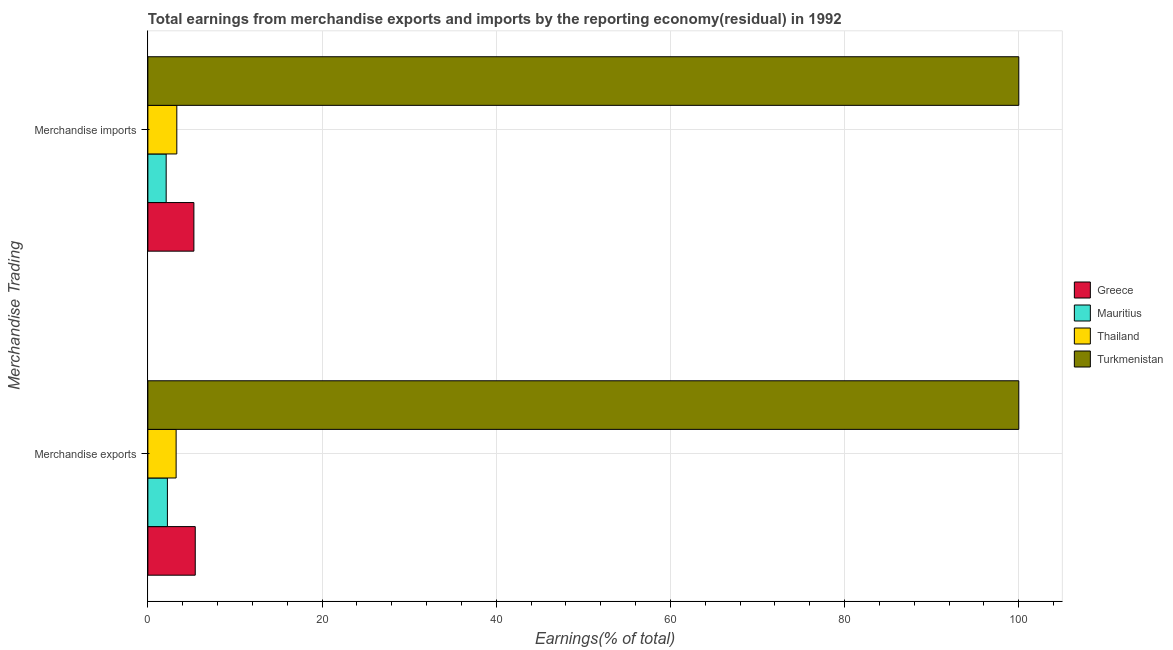How many groups of bars are there?
Your answer should be very brief. 2. Are the number of bars per tick equal to the number of legend labels?
Provide a succinct answer. Yes. How many bars are there on the 1st tick from the top?
Provide a succinct answer. 4. How many bars are there on the 2nd tick from the bottom?
Provide a short and direct response. 4. What is the label of the 1st group of bars from the top?
Offer a terse response. Merchandise imports. Across all countries, what is the minimum earnings from merchandise imports?
Offer a very short reply. 2.1. In which country was the earnings from merchandise imports maximum?
Ensure brevity in your answer.  Turkmenistan. In which country was the earnings from merchandise imports minimum?
Make the answer very short. Mauritius. What is the total earnings from merchandise imports in the graph?
Keep it short and to the point. 110.71. What is the difference between the earnings from merchandise imports in Mauritius and that in Turkmenistan?
Your answer should be very brief. -97.9. What is the difference between the earnings from merchandise exports in Thailand and the earnings from merchandise imports in Turkmenistan?
Your answer should be compact. -96.75. What is the average earnings from merchandise exports per country?
Your response must be concise. 27.73. What is the ratio of the earnings from merchandise exports in Turkmenistan to that in Thailand?
Your answer should be very brief. 30.81. Is the earnings from merchandise exports in Mauritius less than that in Turkmenistan?
Give a very brief answer. Yes. In how many countries, is the earnings from merchandise imports greater than the average earnings from merchandise imports taken over all countries?
Your answer should be very brief. 1. Are all the bars in the graph horizontal?
Offer a terse response. Yes. How many countries are there in the graph?
Your answer should be compact. 4. What is the difference between two consecutive major ticks on the X-axis?
Offer a very short reply. 20. Are the values on the major ticks of X-axis written in scientific E-notation?
Offer a very short reply. No. Does the graph contain grids?
Ensure brevity in your answer.  Yes. Where does the legend appear in the graph?
Offer a very short reply. Center right. How many legend labels are there?
Provide a short and direct response. 4. What is the title of the graph?
Your answer should be compact. Total earnings from merchandise exports and imports by the reporting economy(residual) in 1992. What is the label or title of the X-axis?
Provide a short and direct response. Earnings(% of total). What is the label or title of the Y-axis?
Offer a very short reply. Merchandise Trading. What is the Earnings(% of total) of Greece in Merchandise exports?
Your answer should be compact. 5.44. What is the Earnings(% of total) of Mauritius in Merchandise exports?
Offer a terse response. 2.24. What is the Earnings(% of total) of Thailand in Merchandise exports?
Provide a succinct answer. 3.25. What is the Earnings(% of total) of Turkmenistan in Merchandise exports?
Your response must be concise. 100. What is the Earnings(% of total) of Greece in Merchandise imports?
Provide a succinct answer. 5.28. What is the Earnings(% of total) in Mauritius in Merchandise imports?
Provide a succinct answer. 2.1. What is the Earnings(% of total) in Thailand in Merchandise imports?
Give a very brief answer. 3.32. What is the Earnings(% of total) in Turkmenistan in Merchandise imports?
Ensure brevity in your answer.  100. Across all Merchandise Trading, what is the maximum Earnings(% of total) in Greece?
Keep it short and to the point. 5.44. Across all Merchandise Trading, what is the maximum Earnings(% of total) in Mauritius?
Offer a very short reply. 2.24. Across all Merchandise Trading, what is the maximum Earnings(% of total) of Thailand?
Your answer should be compact. 3.32. Across all Merchandise Trading, what is the minimum Earnings(% of total) in Greece?
Provide a succinct answer. 5.28. Across all Merchandise Trading, what is the minimum Earnings(% of total) in Mauritius?
Your answer should be very brief. 2.1. Across all Merchandise Trading, what is the minimum Earnings(% of total) of Thailand?
Make the answer very short. 3.25. Across all Merchandise Trading, what is the minimum Earnings(% of total) of Turkmenistan?
Your answer should be compact. 100. What is the total Earnings(% of total) in Greece in the graph?
Keep it short and to the point. 10.72. What is the total Earnings(% of total) of Mauritius in the graph?
Your answer should be very brief. 4.34. What is the total Earnings(% of total) in Thailand in the graph?
Make the answer very short. 6.57. What is the difference between the Earnings(% of total) in Greece in Merchandise exports and that in Merchandise imports?
Your answer should be very brief. 0.16. What is the difference between the Earnings(% of total) of Mauritius in Merchandise exports and that in Merchandise imports?
Offer a very short reply. 0.14. What is the difference between the Earnings(% of total) in Thailand in Merchandise exports and that in Merchandise imports?
Provide a succinct answer. -0.08. What is the difference between the Earnings(% of total) of Greece in Merchandise exports and the Earnings(% of total) of Mauritius in Merchandise imports?
Your answer should be compact. 3.34. What is the difference between the Earnings(% of total) in Greece in Merchandise exports and the Earnings(% of total) in Thailand in Merchandise imports?
Your answer should be compact. 2.12. What is the difference between the Earnings(% of total) in Greece in Merchandise exports and the Earnings(% of total) in Turkmenistan in Merchandise imports?
Keep it short and to the point. -94.56. What is the difference between the Earnings(% of total) in Mauritius in Merchandise exports and the Earnings(% of total) in Thailand in Merchandise imports?
Provide a succinct answer. -1.08. What is the difference between the Earnings(% of total) of Mauritius in Merchandise exports and the Earnings(% of total) of Turkmenistan in Merchandise imports?
Offer a terse response. -97.76. What is the difference between the Earnings(% of total) of Thailand in Merchandise exports and the Earnings(% of total) of Turkmenistan in Merchandise imports?
Offer a very short reply. -96.75. What is the average Earnings(% of total) in Greece per Merchandise Trading?
Provide a succinct answer. 5.36. What is the average Earnings(% of total) in Mauritius per Merchandise Trading?
Your answer should be very brief. 2.17. What is the average Earnings(% of total) in Thailand per Merchandise Trading?
Your response must be concise. 3.28. What is the difference between the Earnings(% of total) of Greece and Earnings(% of total) of Mauritius in Merchandise exports?
Provide a succinct answer. 3.2. What is the difference between the Earnings(% of total) of Greece and Earnings(% of total) of Thailand in Merchandise exports?
Offer a very short reply. 2.19. What is the difference between the Earnings(% of total) in Greece and Earnings(% of total) in Turkmenistan in Merchandise exports?
Your answer should be compact. -94.56. What is the difference between the Earnings(% of total) of Mauritius and Earnings(% of total) of Thailand in Merchandise exports?
Provide a short and direct response. -1. What is the difference between the Earnings(% of total) in Mauritius and Earnings(% of total) in Turkmenistan in Merchandise exports?
Your answer should be very brief. -97.76. What is the difference between the Earnings(% of total) in Thailand and Earnings(% of total) in Turkmenistan in Merchandise exports?
Make the answer very short. -96.75. What is the difference between the Earnings(% of total) of Greece and Earnings(% of total) of Mauritius in Merchandise imports?
Ensure brevity in your answer.  3.18. What is the difference between the Earnings(% of total) of Greece and Earnings(% of total) of Thailand in Merchandise imports?
Give a very brief answer. 1.96. What is the difference between the Earnings(% of total) of Greece and Earnings(% of total) of Turkmenistan in Merchandise imports?
Keep it short and to the point. -94.72. What is the difference between the Earnings(% of total) of Mauritius and Earnings(% of total) of Thailand in Merchandise imports?
Your answer should be compact. -1.22. What is the difference between the Earnings(% of total) of Mauritius and Earnings(% of total) of Turkmenistan in Merchandise imports?
Provide a succinct answer. -97.9. What is the difference between the Earnings(% of total) in Thailand and Earnings(% of total) in Turkmenistan in Merchandise imports?
Your answer should be compact. -96.68. What is the ratio of the Earnings(% of total) in Greece in Merchandise exports to that in Merchandise imports?
Make the answer very short. 1.03. What is the ratio of the Earnings(% of total) in Mauritius in Merchandise exports to that in Merchandise imports?
Offer a very short reply. 1.07. What is the ratio of the Earnings(% of total) of Thailand in Merchandise exports to that in Merchandise imports?
Keep it short and to the point. 0.98. What is the difference between the highest and the second highest Earnings(% of total) of Greece?
Your response must be concise. 0.16. What is the difference between the highest and the second highest Earnings(% of total) of Mauritius?
Provide a short and direct response. 0.14. What is the difference between the highest and the second highest Earnings(% of total) of Thailand?
Provide a succinct answer. 0.08. What is the difference between the highest and the lowest Earnings(% of total) of Greece?
Make the answer very short. 0.16. What is the difference between the highest and the lowest Earnings(% of total) of Mauritius?
Provide a short and direct response. 0.14. What is the difference between the highest and the lowest Earnings(% of total) in Thailand?
Make the answer very short. 0.08. 